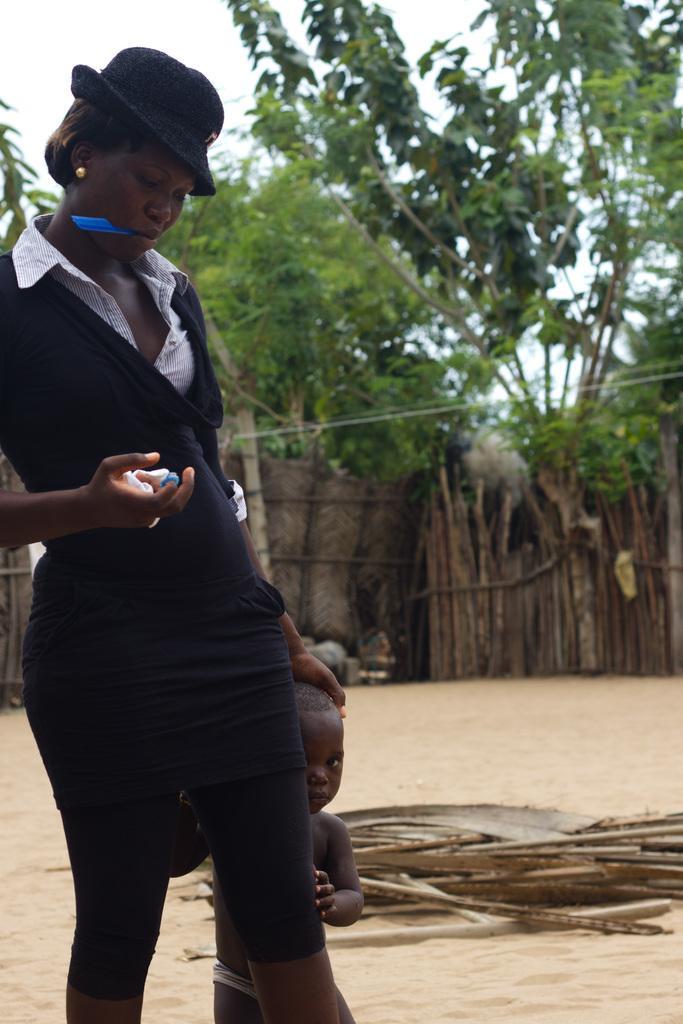How would you summarize this image in a sentence or two? In this image we can see a woman and in her mouth we can see an object. The woman is holding an object. Behind the woman we can see a kid. There are wooden objects in the sand. In the background, we can see the fencing and trees. At the top we can see the sky. 